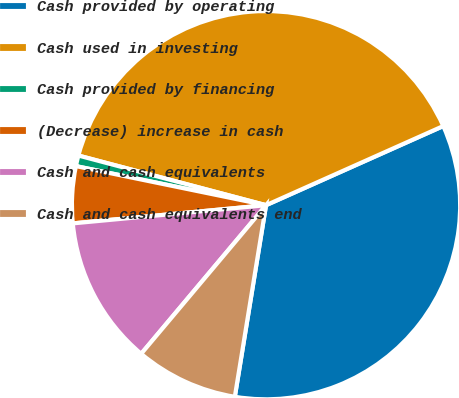Convert chart. <chart><loc_0><loc_0><loc_500><loc_500><pie_chart><fcel>Cash provided by operating<fcel>Cash used in investing<fcel>Cash provided by financing<fcel>(Decrease) increase in cash<fcel>Cash and cash equivalents<fcel>Cash and cash equivalents end<nl><fcel>34.25%<fcel>39.19%<fcel>0.89%<fcel>4.72%<fcel>12.38%<fcel>8.55%<nl></chart> 